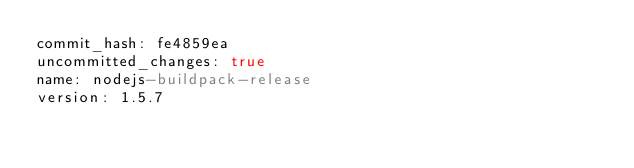<code> <loc_0><loc_0><loc_500><loc_500><_YAML_>commit_hash: fe4859ea
uncommitted_changes: true
name: nodejs-buildpack-release
version: 1.5.7
</code> 